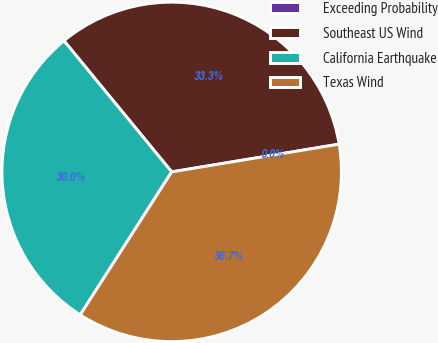Convert chart. <chart><loc_0><loc_0><loc_500><loc_500><pie_chart><fcel>Exceeding Probability<fcel>Southeast US Wind<fcel>California Earthquake<fcel>Texas Wind<nl><fcel>0.0%<fcel>33.33%<fcel>29.99%<fcel>36.67%<nl></chart> 